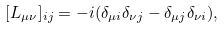<formula> <loc_0><loc_0><loc_500><loc_500>[ L _ { \mu \nu } ] _ { i j } = - i ( \delta _ { \mu i } \delta _ { \nu j } - \delta _ { \mu j } \delta _ { \nu i } ) ,</formula> 